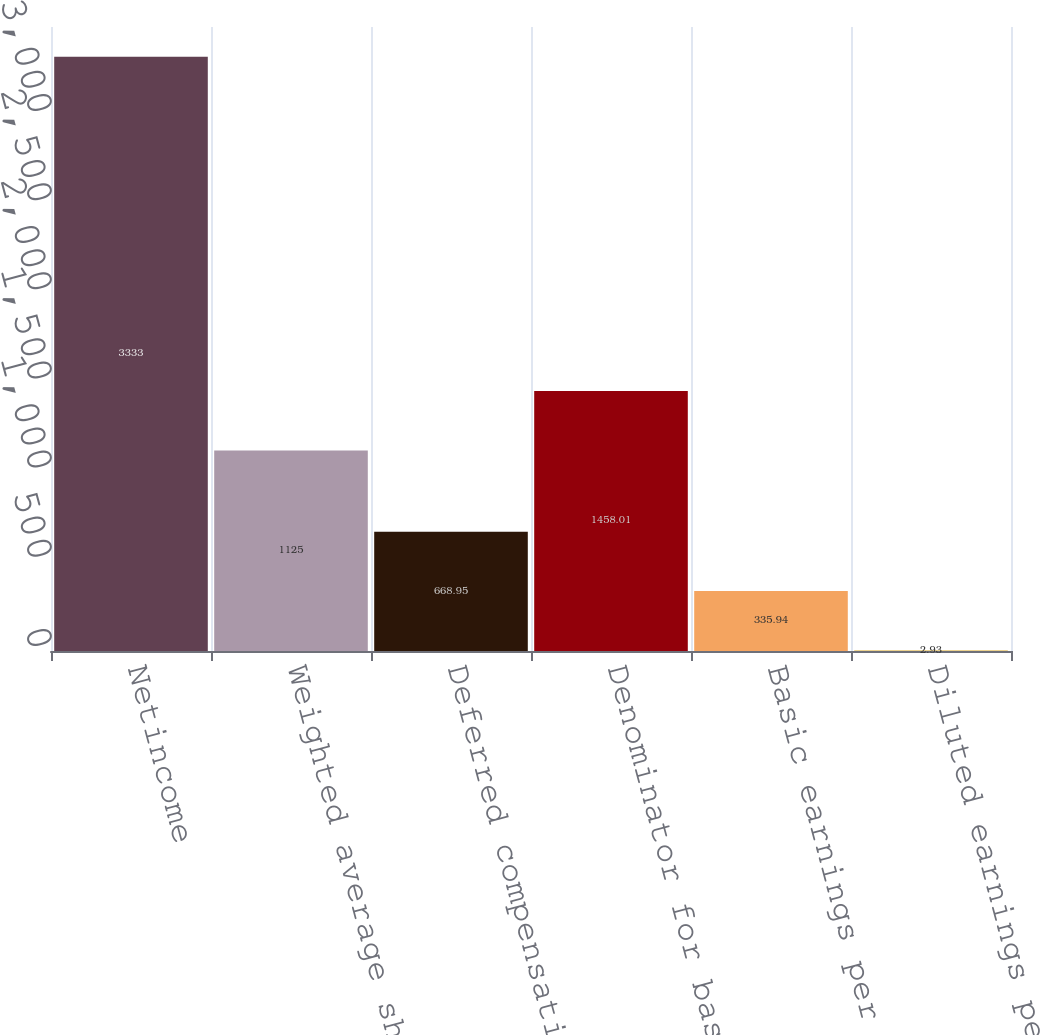Convert chart to OTSL. <chart><loc_0><loc_0><loc_500><loc_500><bar_chart><fcel>Netincome<fcel>Weighted average shares<fcel>Deferred compensation<fcel>Denominator for basic earnings<fcel>Basic earnings per share<fcel>Diluted earnings per share<nl><fcel>3333<fcel>1125<fcel>668.95<fcel>1458.01<fcel>335.94<fcel>2.93<nl></chart> 